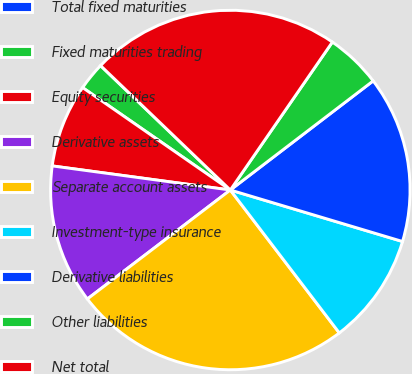Convert chart. <chart><loc_0><loc_0><loc_500><loc_500><pie_chart><fcel>Total fixed maturities<fcel>Fixed maturities trading<fcel>Equity securities<fcel>Derivative assets<fcel>Separate account assets<fcel>Investment-type insurance<fcel>Derivative liabilities<fcel>Other liabilities<fcel>Net total<nl><fcel>0.01%<fcel>2.51%<fcel>7.51%<fcel>12.51%<fcel>25.01%<fcel>10.01%<fcel>15.01%<fcel>5.01%<fcel>22.45%<nl></chart> 